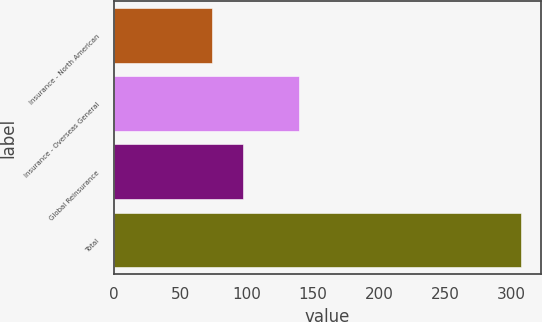<chart> <loc_0><loc_0><loc_500><loc_500><bar_chart><fcel>Insurance - North American<fcel>Insurance - Overseas General<fcel>Global Reinsurance<fcel>Total<nl><fcel>74<fcel>140<fcel>97.3<fcel>307<nl></chart> 